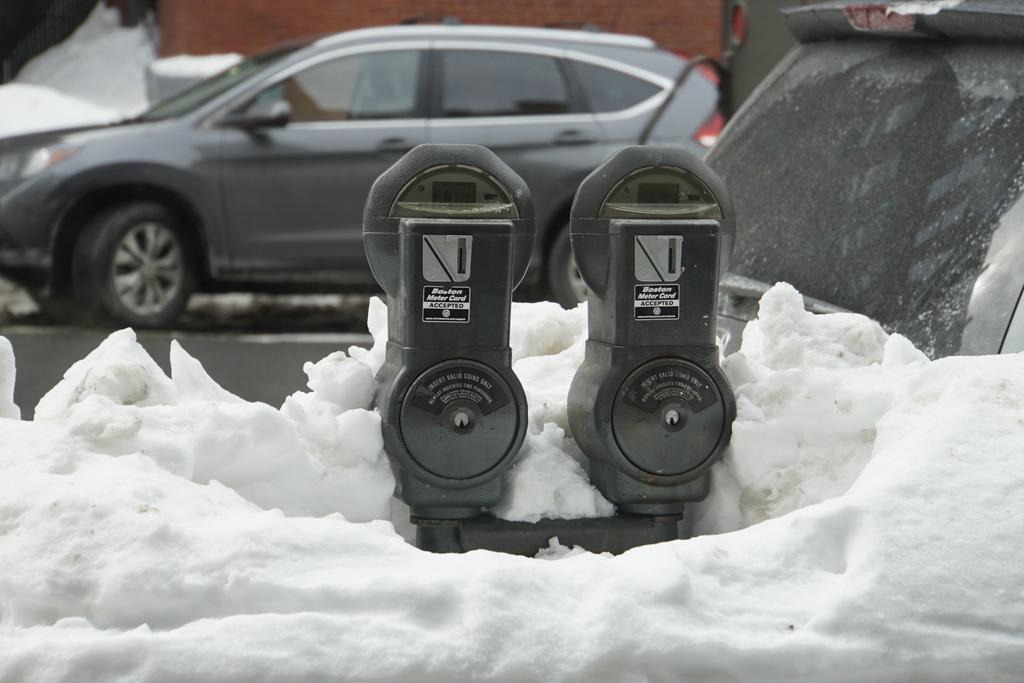Is there any time left on the meter?
Provide a short and direct response. Unanswerable. 